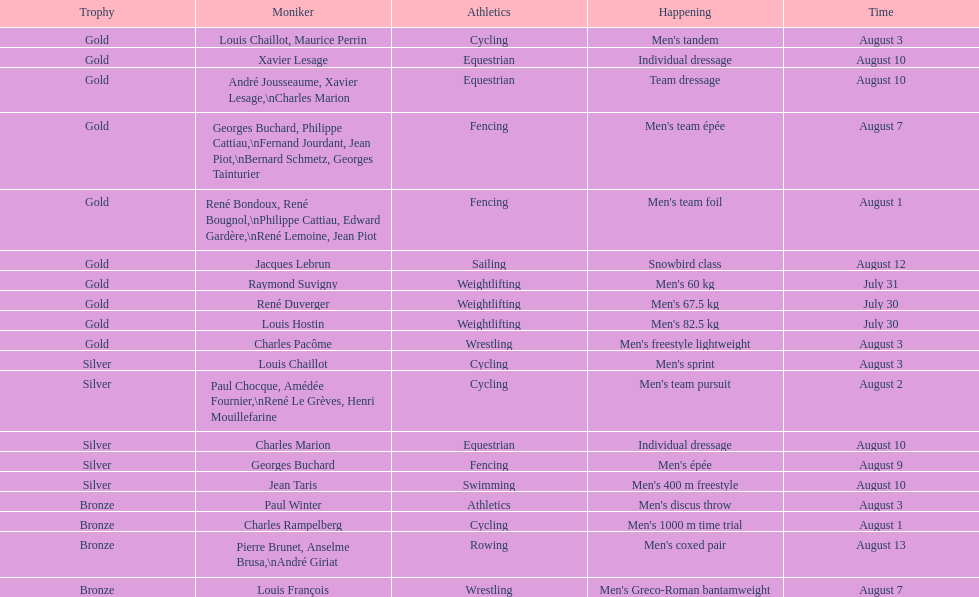What is next date that is listed after august 7th? August 1. 